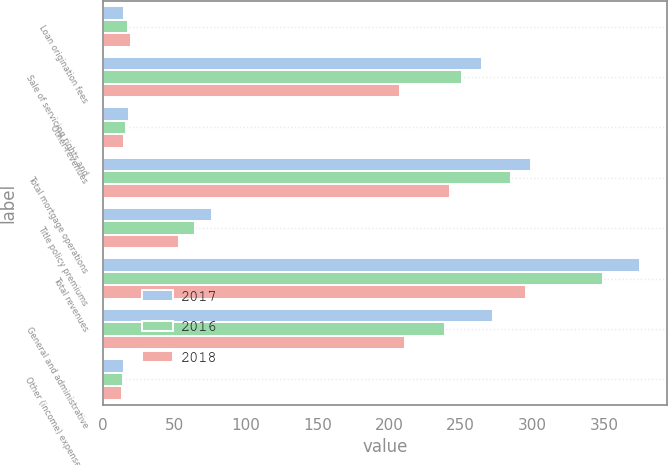Convert chart. <chart><loc_0><loc_0><loc_500><loc_500><stacked_bar_chart><ecel><fcel>Loan origination fees<fcel>Sale of servicing rights and<fcel>Other revenues<fcel>Total mortgage operations<fcel>Title policy premiums<fcel>Total revenues<fcel>General and administrative<fcel>Other (income) expense (1)<nl><fcel>2017<fcel>15<fcel>265.1<fcel>18.7<fcel>298.8<fcel>76.5<fcel>375.3<fcel>272.6<fcel>15.1<nl><fcel>2016<fcel>17.7<fcel>251.1<fcel>16.5<fcel>285.3<fcel>64.2<fcel>349.5<fcel>239.3<fcel>14.3<nl><fcel>2018<fcel>20.1<fcel>207.5<fcel>14.6<fcel>242.2<fcel>53.4<fcel>295.6<fcel>211.2<fcel>13.7<nl></chart> 